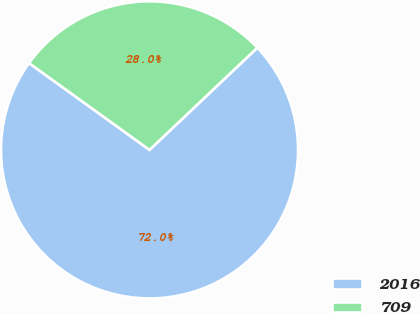Convert chart. <chart><loc_0><loc_0><loc_500><loc_500><pie_chart><fcel>2016<fcel>709<nl><fcel>72.01%<fcel>27.99%<nl></chart> 